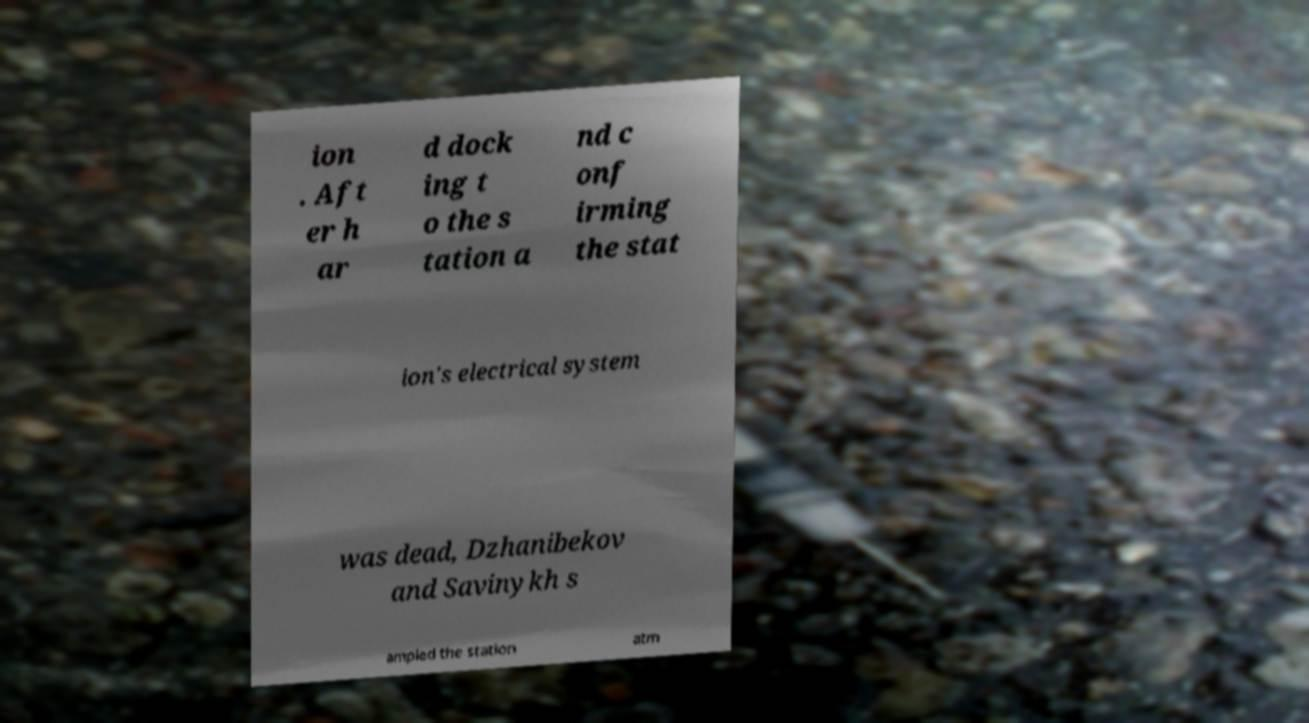I need the written content from this picture converted into text. Can you do that? ion . Aft er h ar d dock ing t o the s tation a nd c onf irming the stat ion's electrical system was dead, Dzhanibekov and Savinykh s ampled the station atm 